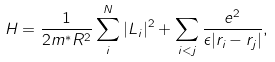<formula> <loc_0><loc_0><loc_500><loc_500>H = \frac { 1 } { 2 m ^ { * } R ^ { 2 } } \sum _ { i } ^ { N } | { L } _ { i } | ^ { 2 } + \sum _ { i < j } \frac { e ^ { 2 } } { \epsilon | { r } _ { i } - { r } _ { j } | } ,</formula> 